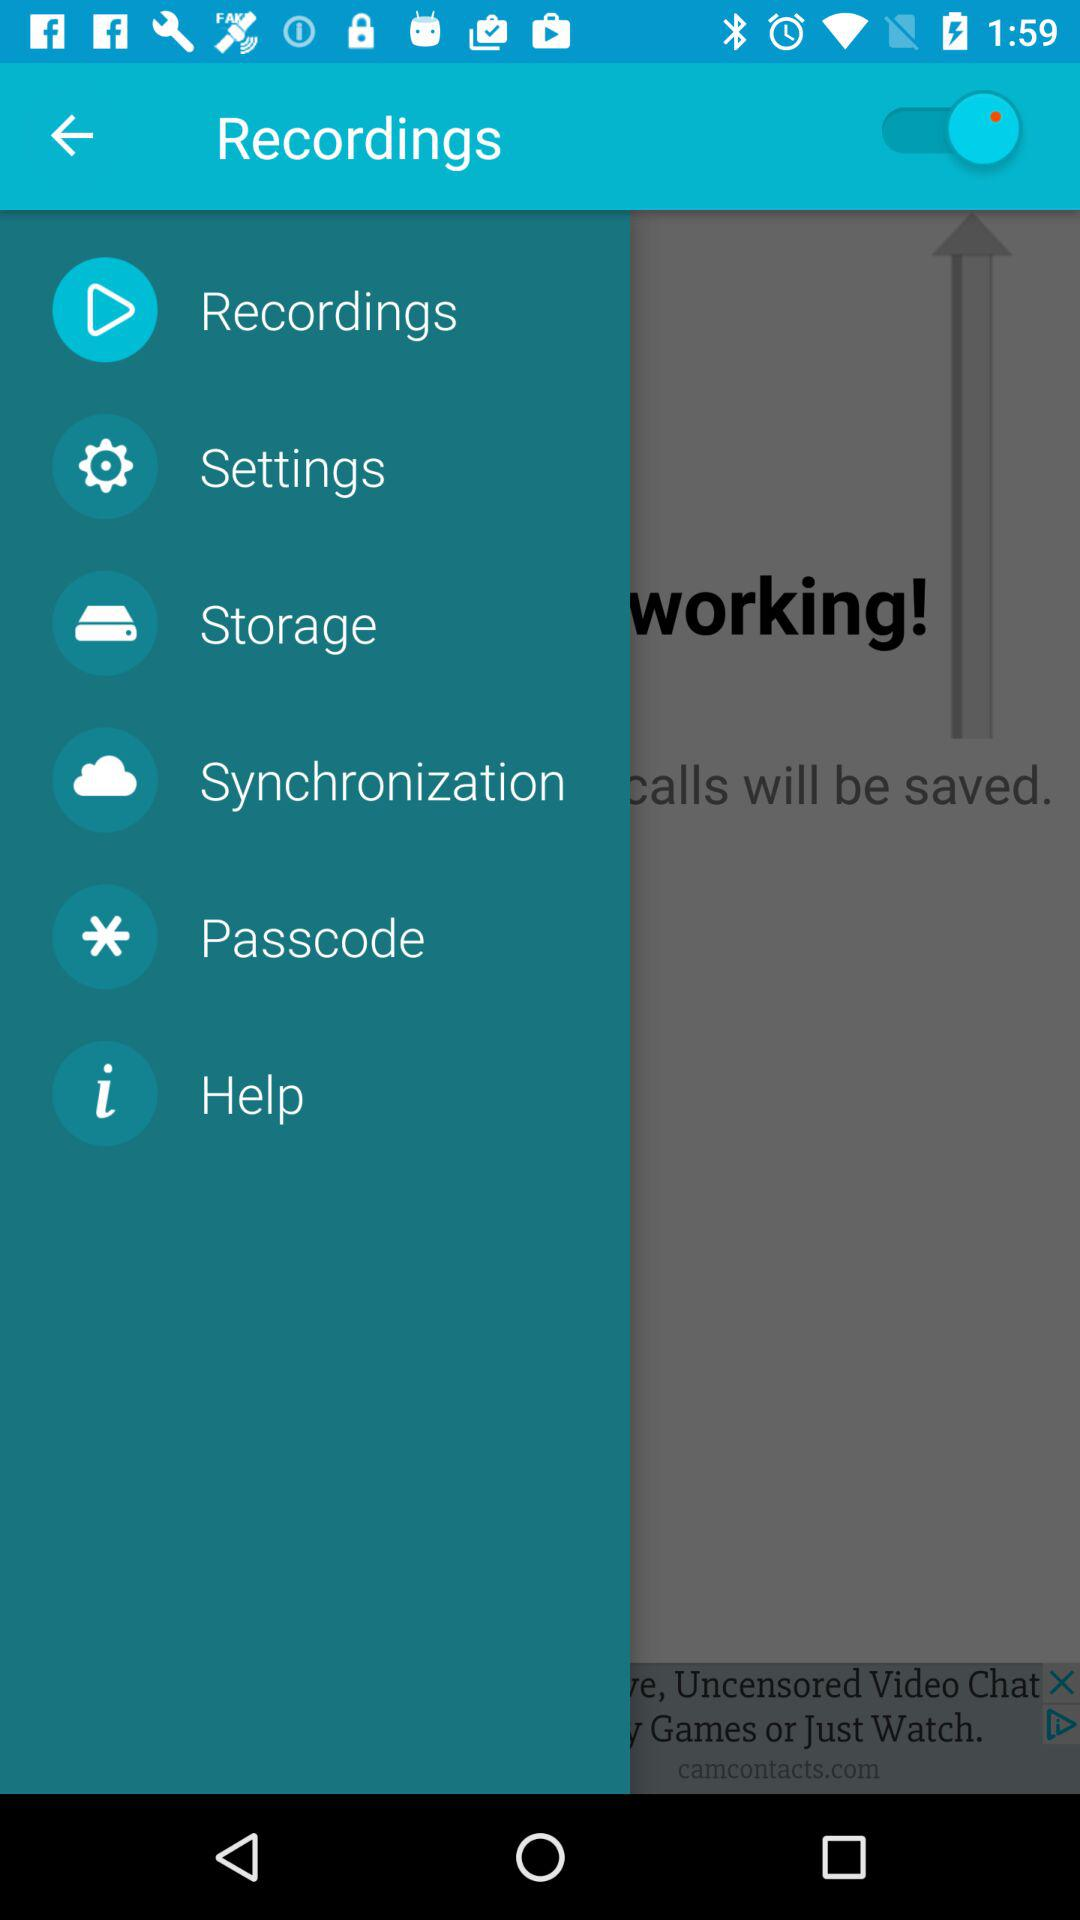What is the status of "Recordings"? The status is "on". 